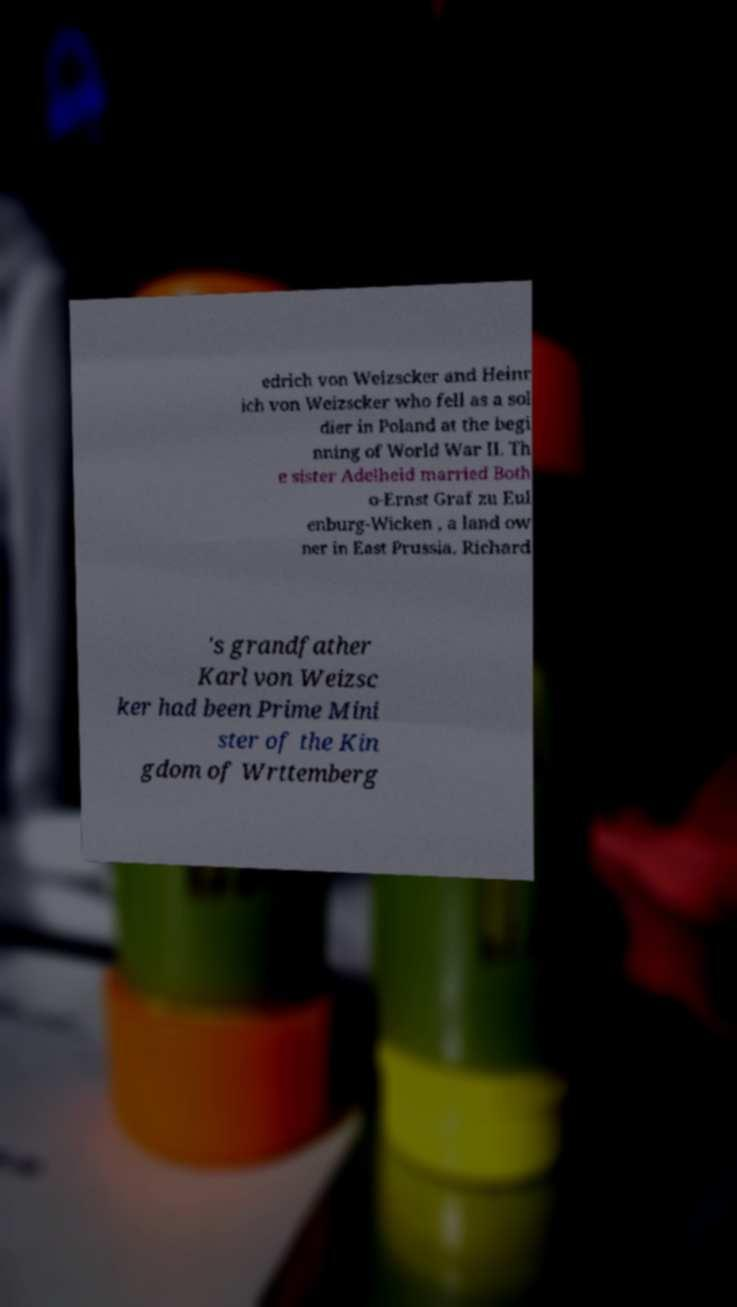There's text embedded in this image that I need extracted. Can you transcribe it verbatim? edrich von Weizscker and Heinr ich von Weizscker who fell as a sol dier in Poland at the begi nning of World War II. Th e sister Adelheid married Both o-Ernst Graf zu Eul enburg-Wicken , a land ow ner in East Prussia. Richard 's grandfather Karl von Weizsc ker had been Prime Mini ster of the Kin gdom of Wrttemberg 